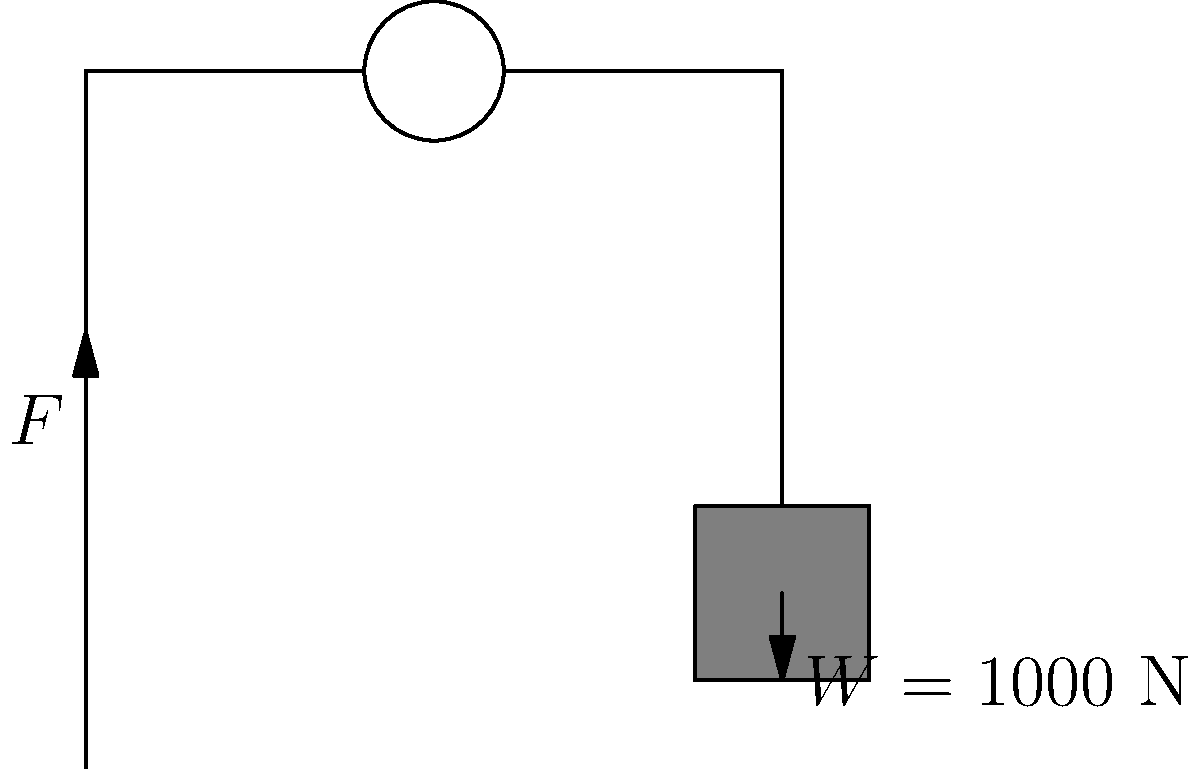As a restoration expert, you're tasked with lifting a delicate antique statue weighing 1000 N using a pulley system. The pulley is frictionless and the rope is considered massless. What force $F$ is required to lift the statue, and how does this compare to lifting it without a pulley? How might this knowledge influence your restoration techniques? Let's approach this step-by-step:

1) In a single pulley system, the tension in the rope is the same throughout.

2) The weight of the statue ($W$) is balanced by two sections of rope, each with tension $F$.

3) We can write the force balance equation:
   $$W = 2F$$

4) Substituting the given weight:
   $$1000 \textrm{ N} = 2F$$

5) Solving for $F$:
   $$F = \frac{1000 \textrm{ N}}{2} = 500 \textrm{ N}$$

6) Comparison to lifting without a pulley:
   Without a pulley, you would need to apply a force equal to the full weight (1000 N).
   With the pulley, you only need to apply half the force (500 N).

7) Influence on restoration techniques:
   This pulley system reduces the required force by 50%, allowing for more precise control and reducing the risk of damage to delicate artifacts. It also reduces physical strain on the restorer, enabling more careful and sustained work on challenging projects.
Answer: $F = 500 \textrm{ N}$ 